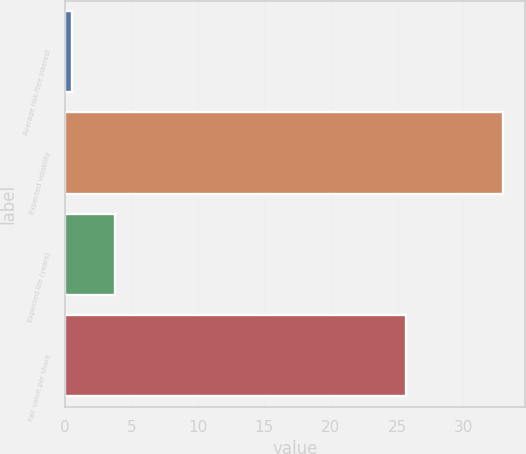Convert chart to OTSL. <chart><loc_0><loc_0><loc_500><loc_500><bar_chart><fcel>Average risk-free interest<fcel>Expected volatility<fcel>Expected life (years)<fcel>Fair value per share<nl><fcel>0.5<fcel>33<fcel>3.75<fcel>25.69<nl></chart> 